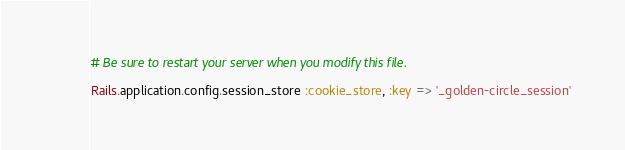<code> <loc_0><loc_0><loc_500><loc_500><_Ruby_># Be sure to restart your server when you modify this file.

Rails.application.config.session_store :cookie_store, :key => '_golden-circle_session'
</code> 